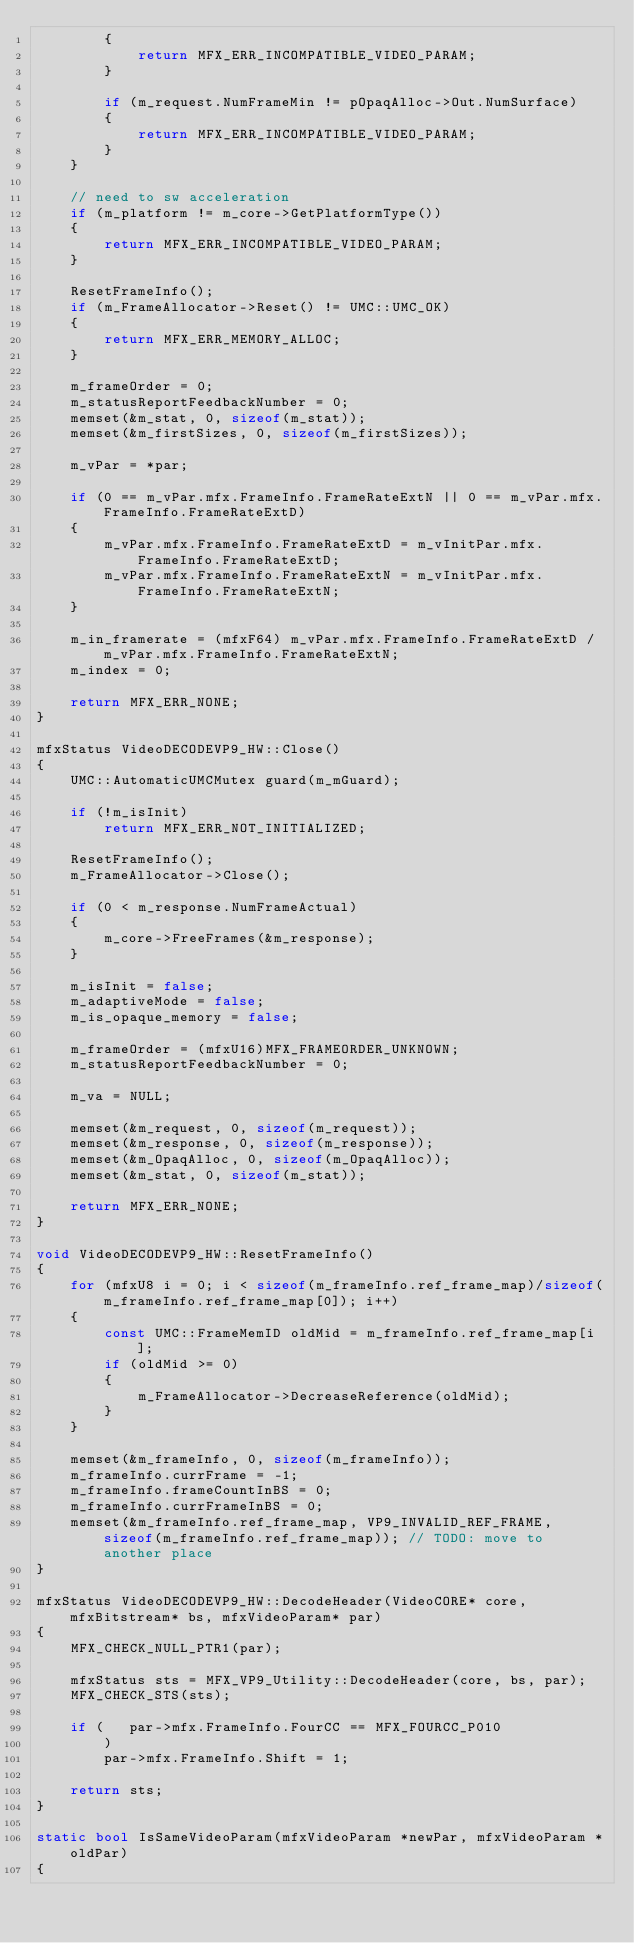<code> <loc_0><loc_0><loc_500><loc_500><_C++_>        {
            return MFX_ERR_INCOMPATIBLE_VIDEO_PARAM;
        }

        if (m_request.NumFrameMin != pOpaqAlloc->Out.NumSurface)
        {
            return MFX_ERR_INCOMPATIBLE_VIDEO_PARAM;
        }
    }

    // need to sw acceleration
    if (m_platform != m_core->GetPlatformType())
    {
        return MFX_ERR_INCOMPATIBLE_VIDEO_PARAM;
    }

    ResetFrameInfo();
    if (m_FrameAllocator->Reset() != UMC::UMC_OK)
    {
        return MFX_ERR_MEMORY_ALLOC;
    }

    m_frameOrder = 0;
    m_statusReportFeedbackNumber = 0;
    memset(&m_stat, 0, sizeof(m_stat));
    memset(&m_firstSizes, 0, sizeof(m_firstSizes));

    m_vPar = *par;

    if (0 == m_vPar.mfx.FrameInfo.FrameRateExtN || 0 == m_vPar.mfx.FrameInfo.FrameRateExtD)
    {
        m_vPar.mfx.FrameInfo.FrameRateExtD = m_vInitPar.mfx.FrameInfo.FrameRateExtD;
        m_vPar.mfx.FrameInfo.FrameRateExtN = m_vInitPar.mfx.FrameInfo.FrameRateExtN;
    }

    m_in_framerate = (mfxF64) m_vPar.mfx.FrameInfo.FrameRateExtD / m_vPar.mfx.FrameInfo.FrameRateExtN;
    m_index = 0;

    return MFX_ERR_NONE;
}

mfxStatus VideoDECODEVP9_HW::Close()
{
    UMC::AutomaticUMCMutex guard(m_mGuard);

    if (!m_isInit)
        return MFX_ERR_NOT_INITIALIZED;

    ResetFrameInfo();
    m_FrameAllocator->Close();

    if (0 < m_response.NumFrameActual)
    {
        m_core->FreeFrames(&m_response);
    }

    m_isInit = false;
    m_adaptiveMode = false;
    m_is_opaque_memory = false;

    m_frameOrder = (mfxU16)MFX_FRAMEORDER_UNKNOWN;
    m_statusReportFeedbackNumber = 0;

    m_va = NULL;

    memset(&m_request, 0, sizeof(m_request));
    memset(&m_response, 0, sizeof(m_response));
    memset(&m_OpaqAlloc, 0, sizeof(m_OpaqAlloc));
    memset(&m_stat, 0, sizeof(m_stat));

    return MFX_ERR_NONE;
}

void VideoDECODEVP9_HW::ResetFrameInfo()
{
    for (mfxU8 i = 0; i < sizeof(m_frameInfo.ref_frame_map)/sizeof(m_frameInfo.ref_frame_map[0]); i++)
    {
        const UMC::FrameMemID oldMid = m_frameInfo.ref_frame_map[i];
        if (oldMid >= 0)
        {
            m_FrameAllocator->DecreaseReference(oldMid);
        }
    }

    memset(&m_frameInfo, 0, sizeof(m_frameInfo));
    m_frameInfo.currFrame = -1;
    m_frameInfo.frameCountInBS = 0;
    m_frameInfo.currFrameInBS = 0;
    memset(&m_frameInfo.ref_frame_map, VP9_INVALID_REF_FRAME, sizeof(m_frameInfo.ref_frame_map)); // TODO: move to another place
}

mfxStatus VideoDECODEVP9_HW::DecodeHeader(VideoCORE* core, mfxBitstream* bs, mfxVideoParam* par)
{
    MFX_CHECK_NULL_PTR1(par);

    mfxStatus sts = MFX_VP9_Utility::DecodeHeader(core, bs, par);
    MFX_CHECK_STS(sts);

    if (   par->mfx.FrameInfo.FourCC == MFX_FOURCC_P010
        )
        par->mfx.FrameInfo.Shift = 1;

    return sts;
}

static bool IsSameVideoParam(mfxVideoParam *newPar, mfxVideoParam *oldPar)
{</code> 